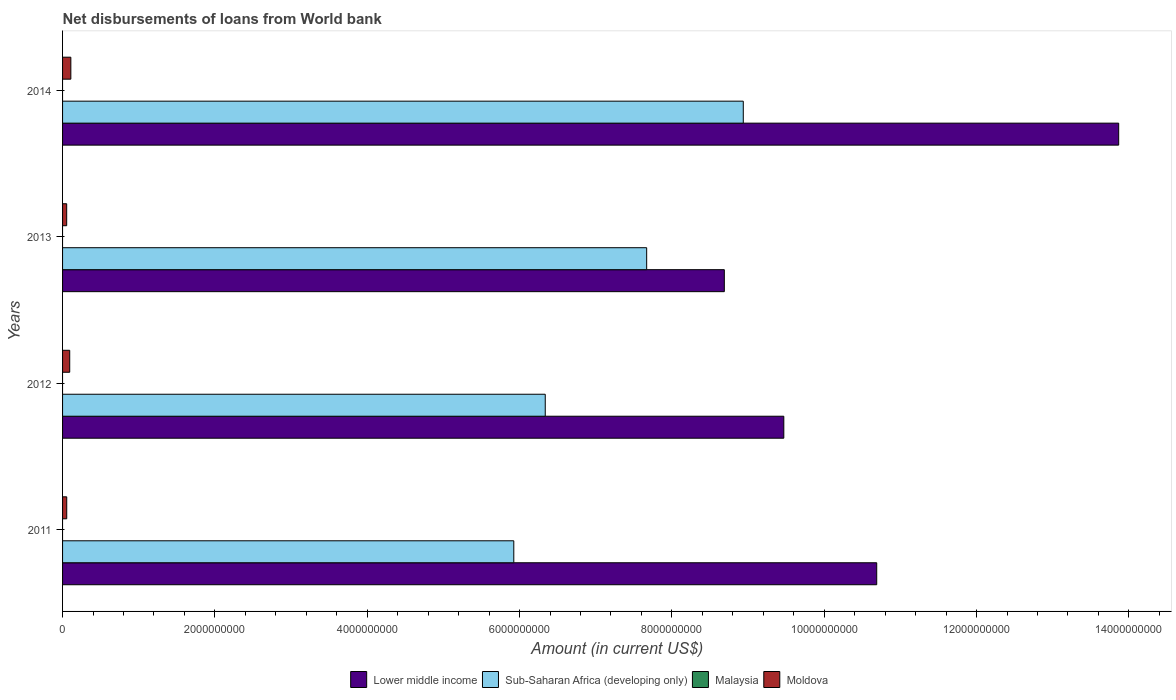What is the label of the 4th group of bars from the top?
Provide a succinct answer. 2011. Across all years, what is the maximum amount of loan disbursed from World Bank in Moldova?
Your response must be concise. 1.09e+08. Across all years, what is the minimum amount of loan disbursed from World Bank in Moldova?
Your response must be concise. 5.40e+07. What is the total amount of loan disbursed from World Bank in Moldova in the graph?
Provide a short and direct response. 3.11e+08. What is the difference between the amount of loan disbursed from World Bank in Moldova in 2011 and that in 2014?
Offer a terse response. -5.39e+07. What is the difference between the amount of loan disbursed from World Bank in Lower middle income in 2013 and the amount of loan disbursed from World Bank in Sub-Saharan Africa (developing only) in 2012?
Make the answer very short. 2.35e+09. What is the average amount of loan disbursed from World Bank in Lower middle income per year?
Ensure brevity in your answer.  1.07e+1. In the year 2012, what is the difference between the amount of loan disbursed from World Bank in Moldova and amount of loan disbursed from World Bank in Sub-Saharan Africa (developing only)?
Provide a short and direct response. -6.24e+09. In how many years, is the amount of loan disbursed from World Bank in Moldova greater than 10800000000 US$?
Keep it short and to the point. 0. What is the ratio of the amount of loan disbursed from World Bank in Sub-Saharan Africa (developing only) in 2013 to that in 2014?
Your answer should be very brief. 0.86. Is the amount of loan disbursed from World Bank in Sub-Saharan Africa (developing only) in 2011 less than that in 2012?
Provide a short and direct response. Yes. Is the difference between the amount of loan disbursed from World Bank in Moldova in 2012 and 2013 greater than the difference between the amount of loan disbursed from World Bank in Sub-Saharan Africa (developing only) in 2012 and 2013?
Give a very brief answer. Yes. What is the difference between the highest and the second highest amount of loan disbursed from World Bank in Moldova?
Keep it short and to the point. 1.47e+07. What is the difference between the highest and the lowest amount of loan disbursed from World Bank in Moldova?
Offer a terse response. 5.46e+07. Is the sum of the amount of loan disbursed from World Bank in Moldova in 2011 and 2012 greater than the maximum amount of loan disbursed from World Bank in Malaysia across all years?
Make the answer very short. Yes. Is it the case that in every year, the sum of the amount of loan disbursed from World Bank in Malaysia and amount of loan disbursed from World Bank in Moldova is greater than the sum of amount of loan disbursed from World Bank in Sub-Saharan Africa (developing only) and amount of loan disbursed from World Bank in Lower middle income?
Offer a very short reply. No. Is it the case that in every year, the sum of the amount of loan disbursed from World Bank in Malaysia and amount of loan disbursed from World Bank in Moldova is greater than the amount of loan disbursed from World Bank in Sub-Saharan Africa (developing only)?
Provide a short and direct response. No. Are the values on the major ticks of X-axis written in scientific E-notation?
Provide a short and direct response. No. Where does the legend appear in the graph?
Your response must be concise. Bottom center. What is the title of the graph?
Make the answer very short. Net disbursements of loans from World bank. What is the Amount (in current US$) in Lower middle income in 2011?
Provide a succinct answer. 1.07e+1. What is the Amount (in current US$) in Sub-Saharan Africa (developing only) in 2011?
Provide a succinct answer. 5.92e+09. What is the Amount (in current US$) in Moldova in 2011?
Your answer should be very brief. 5.47e+07. What is the Amount (in current US$) of Lower middle income in 2012?
Offer a terse response. 9.47e+09. What is the Amount (in current US$) in Sub-Saharan Africa (developing only) in 2012?
Offer a very short reply. 6.34e+09. What is the Amount (in current US$) of Moldova in 2012?
Provide a succinct answer. 9.39e+07. What is the Amount (in current US$) of Lower middle income in 2013?
Your response must be concise. 8.69e+09. What is the Amount (in current US$) of Sub-Saharan Africa (developing only) in 2013?
Your answer should be very brief. 7.67e+09. What is the Amount (in current US$) in Moldova in 2013?
Ensure brevity in your answer.  5.40e+07. What is the Amount (in current US$) in Lower middle income in 2014?
Provide a short and direct response. 1.39e+1. What is the Amount (in current US$) in Sub-Saharan Africa (developing only) in 2014?
Your answer should be very brief. 8.94e+09. What is the Amount (in current US$) in Moldova in 2014?
Ensure brevity in your answer.  1.09e+08. Across all years, what is the maximum Amount (in current US$) of Lower middle income?
Ensure brevity in your answer.  1.39e+1. Across all years, what is the maximum Amount (in current US$) in Sub-Saharan Africa (developing only)?
Provide a short and direct response. 8.94e+09. Across all years, what is the maximum Amount (in current US$) in Moldova?
Make the answer very short. 1.09e+08. Across all years, what is the minimum Amount (in current US$) in Lower middle income?
Make the answer very short. 8.69e+09. Across all years, what is the minimum Amount (in current US$) in Sub-Saharan Africa (developing only)?
Your answer should be very brief. 5.92e+09. Across all years, what is the minimum Amount (in current US$) of Moldova?
Your answer should be very brief. 5.40e+07. What is the total Amount (in current US$) in Lower middle income in the graph?
Your response must be concise. 4.27e+1. What is the total Amount (in current US$) of Sub-Saharan Africa (developing only) in the graph?
Offer a very short reply. 2.89e+1. What is the total Amount (in current US$) in Malaysia in the graph?
Keep it short and to the point. 0. What is the total Amount (in current US$) of Moldova in the graph?
Your answer should be very brief. 3.11e+08. What is the difference between the Amount (in current US$) in Lower middle income in 2011 and that in 2012?
Keep it short and to the point. 1.22e+09. What is the difference between the Amount (in current US$) in Sub-Saharan Africa (developing only) in 2011 and that in 2012?
Offer a very short reply. -4.13e+08. What is the difference between the Amount (in current US$) in Moldova in 2011 and that in 2012?
Your response must be concise. -3.92e+07. What is the difference between the Amount (in current US$) in Lower middle income in 2011 and that in 2013?
Your response must be concise. 2.00e+09. What is the difference between the Amount (in current US$) of Sub-Saharan Africa (developing only) in 2011 and that in 2013?
Offer a very short reply. -1.74e+09. What is the difference between the Amount (in current US$) in Moldova in 2011 and that in 2013?
Your answer should be compact. 7.13e+05. What is the difference between the Amount (in current US$) of Lower middle income in 2011 and that in 2014?
Offer a terse response. -3.18e+09. What is the difference between the Amount (in current US$) in Sub-Saharan Africa (developing only) in 2011 and that in 2014?
Offer a very short reply. -3.01e+09. What is the difference between the Amount (in current US$) of Moldova in 2011 and that in 2014?
Your answer should be very brief. -5.39e+07. What is the difference between the Amount (in current US$) in Lower middle income in 2012 and that in 2013?
Make the answer very short. 7.81e+08. What is the difference between the Amount (in current US$) in Sub-Saharan Africa (developing only) in 2012 and that in 2013?
Ensure brevity in your answer.  -1.33e+09. What is the difference between the Amount (in current US$) of Moldova in 2012 and that in 2013?
Your answer should be very brief. 3.99e+07. What is the difference between the Amount (in current US$) in Lower middle income in 2012 and that in 2014?
Your answer should be very brief. -4.40e+09. What is the difference between the Amount (in current US$) of Sub-Saharan Africa (developing only) in 2012 and that in 2014?
Your response must be concise. -2.60e+09. What is the difference between the Amount (in current US$) of Moldova in 2012 and that in 2014?
Keep it short and to the point. -1.47e+07. What is the difference between the Amount (in current US$) of Lower middle income in 2013 and that in 2014?
Your response must be concise. -5.18e+09. What is the difference between the Amount (in current US$) of Sub-Saharan Africa (developing only) in 2013 and that in 2014?
Offer a very short reply. -1.27e+09. What is the difference between the Amount (in current US$) of Moldova in 2013 and that in 2014?
Keep it short and to the point. -5.46e+07. What is the difference between the Amount (in current US$) in Lower middle income in 2011 and the Amount (in current US$) in Sub-Saharan Africa (developing only) in 2012?
Provide a succinct answer. 4.35e+09. What is the difference between the Amount (in current US$) in Lower middle income in 2011 and the Amount (in current US$) in Moldova in 2012?
Your answer should be very brief. 1.06e+1. What is the difference between the Amount (in current US$) in Sub-Saharan Africa (developing only) in 2011 and the Amount (in current US$) in Moldova in 2012?
Provide a succinct answer. 5.83e+09. What is the difference between the Amount (in current US$) of Lower middle income in 2011 and the Amount (in current US$) of Sub-Saharan Africa (developing only) in 2013?
Offer a very short reply. 3.02e+09. What is the difference between the Amount (in current US$) of Lower middle income in 2011 and the Amount (in current US$) of Moldova in 2013?
Your response must be concise. 1.06e+1. What is the difference between the Amount (in current US$) in Sub-Saharan Africa (developing only) in 2011 and the Amount (in current US$) in Moldova in 2013?
Provide a succinct answer. 5.87e+09. What is the difference between the Amount (in current US$) in Lower middle income in 2011 and the Amount (in current US$) in Sub-Saharan Africa (developing only) in 2014?
Give a very brief answer. 1.75e+09. What is the difference between the Amount (in current US$) in Lower middle income in 2011 and the Amount (in current US$) in Moldova in 2014?
Offer a terse response. 1.06e+1. What is the difference between the Amount (in current US$) of Sub-Saharan Africa (developing only) in 2011 and the Amount (in current US$) of Moldova in 2014?
Keep it short and to the point. 5.82e+09. What is the difference between the Amount (in current US$) in Lower middle income in 2012 and the Amount (in current US$) in Sub-Saharan Africa (developing only) in 2013?
Give a very brief answer. 1.80e+09. What is the difference between the Amount (in current US$) in Lower middle income in 2012 and the Amount (in current US$) in Moldova in 2013?
Offer a very short reply. 9.42e+09. What is the difference between the Amount (in current US$) in Sub-Saharan Africa (developing only) in 2012 and the Amount (in current US$) in Moldova in 2013?
Ensure brevity in your answer.  6.28e+09. What is the difference between the Amount (in current US$) of Lower middle income in 2012 and the Amount (in current US$) of Sub-Saharan Africa (developing only) in 2014?
Your response must be concise. 5.32e+08. What is the difference between the Amount (in current US$) of Lower middle income in 2012 and the Amount (in current US$) of Moldova in 2014?
Provide a short and direct response. 9.36e+09. What is the difference between the Amount (in current US$) in Sub-Saharan Africa (developing only) in 2012 and the Amount (in current US$) in Moldova in 2014?
Ensure brevity in your answer.  6.23e+09. What is the difference between the Amount (in current US$) of Lower middle income in 2013 and the Amount (in current US$) of Sub-Saharan Africa (developing only) in 2014?
Offer a terse response. -2.49e+08. What is the difference between the Amount (in current US$) in Lower middle income in 2013 and the Amount (in current US$) in Moldova in 2014?
Provide a succinct answer. 8.58e+09. What is the difference between the Amount (in current US$) in Sub-Saharan Africa (developing only) in 2013 and the Amount (in current US$) in Moldova in 2014?
Your response must be concise. 7.56e+09. What is the average Amount (in current US$) of Lower middle income per year?
Provide a succinct answer. 1.07e+1. What is the average Amount (in current US$) of Sub-Saharan Africa (developing only) per year?
Provide a succinct answer. 7.22e+09. What is the average Amount (in current US$) of Moldova per year?
Keep it short and to the point. 7.78e+07. In the year 2011, what is the difference between the Amount (in current US$) of Lower middle income and Amount (in current US$) of Sub-Saharan Africa (developing only)?
Your answer should be compact. 4.76e+09. In the year 2011, what is the difference between the Amount (in current US$) of Lower middle income and Amount (in current US$) of Moldova?
Make the answer very short. 1.06e+1. In the year 2011, what is the difference between the Amount (in current US$) of Sub-Saharan Africa (developing only) and Amount (in current US$) of Moldova?
Give a very brief answer. 5.87e+09. In the year 2012, what is the difference between the Amount (in current US$) of Lower middle income and Amount (in current US$) of Sub-Saharan Africa (developing only)?
Your answer should be compact. 3.13e+09. In the year 2012, what is the difference between the Amount (in current US$) in Lower middle income and Amount (in current US$) in Moldova?
Keep it short and to the point. 9.38e+09. In the year 2012, what is the difference between the Amount (in current US$) in Sub-Saharan Africa (developing only) and Amount (in current US$) in Moldova?
Provide a succinct answer. 6.24e+09. In the year 2013, what is the difference between the Amount (in current US$) of Lower middle income and Amount (in current US$) of Sub-Saharan Africa (developing only)?
Give a very brief answer. 1.02e+09. In the year 2013, what is the difference between the Amount (in current US$) in Lower middle income and Amount (in current US$) in Moldova?
Your answer should be very brief. 8.63e+09. In the year 2013, what is the difference between the Amount (in current US$) of Sub-Saharan Africa (developing only) and Amount (in current US$) of Moldova?
Offer a very short reply. 7.61e+09. In the year 2014, what is the difference between the Amount (in current US$) in Lower middle income and Amount (in current US$) in Sub-Saharan Africa (developing only)?
Provide a succinct answer. 4.93e+09. In the year 2014, what is the difference between the Amount (in current US$) in Lower middle income and Amount (in current US$) in Moldova?
Provide a succinct answer. 1.38e+1. In the year 2014, what is the difference between the Amount (in current US$) of Sub-Saharan Africa (developing only) and Amount (in current US$) of Moldova?
Keep it short and to the point. 8.83e+09. What is the ratio of the Amount (in current US$) of Lower middle income in 2011 to that in 2012?
Keep it short and to the point. 1.13. What is the ratio of the Amount (in current US$) in Sub-Saharan Africa (developing only) in 2011 to that in 2012?
Ensure brevity in your answer.  0.93. What is the ratio of the Amount (in current US$) of Moldova in 2011 to that in 2012?
Provide a short and direct response. 0.58. What is the ratio of the Amount (in current US$) of Lower middle income in 2011 to that in 2013?
Provide a succinct answer. 1.23. What is the ratio of the Amount (in current US$) in Sub-Saharan Africa (developing only) in 2011 to that in 2013?
Your response must be concise. 0.77. What is the ratio of the Amount (in current US$) in Moldova in 2011 to that in 2013?
Ensure brevity in your answer.  1.01. What is the ratio of the Amount (in current US$) in Lower middle income in 2011 to that in 2014?
Provide a short and direct response. 0.77. What is the ratio of the Amount (in current US$) of Sub-Saharan Africa (developing only) in 2011 to that in 2014?
Make the answer very short. 0.66. What is the ratio of the Amount (in current US$) of Moldova in 2011 to that in 2014?
Give a very brief answer. 0.5. What is the ratio of the Amount (in current US$) in Lower middle income in 2012 to that in 2013?
Offer a very short reply. 1.09. What is the ratio of the Amount (in current US$) in Sub-Saharan Africa (developing only) in 2012 to that in 2013?
Your answer should be compact. 0.83. What is the ratio of the Amount (in current US$) in Moldova in 2012 to that in 2013?
Give a very brief answer. 1.74. What is the ratio of the Amount (in current US$) in Lower middle income in 2012 to that in 2014?
Provide a succinct answer. 0.68. What is the ratio of the Amount (in current US$) of Sub-Saharan Africa (developing only) in 2012 to that in 2014?
Make the answer very short. 0.71. What is the ratio of the Amount (in current US$) in Moldova in 2012 to that in 2014?
Your answer should be compact. 0.86. What is the ratio of the Amount (in current US$) in Lower middle income in 2013 to that in 2014?
Offer a terse response. 0.63. What is the ratio of the Amount (in current US$) in Sub-Saharan Africa (developing only) in 2013 to that in 2014?
Give a very brief answer. 0.86. What is the ratio of the Amount (in current US$) of Moldova in 2013 to that in 2014?
Provide a short and direct response. 0.5. What is the difference between the highest and the second highest Amount (in current US$) in Lower middle income?
Keep it short and to the point. 3.18e+09. What is the difference between the highest and the second highest Amount (in current US$) in Sub-Saharan Africa (developing only)?
Keep it short and to the point. 1.27e+09. What is the difference between the highest and the second highest Amount (in current US$) of Moldova?
Keep it short and to the point. 1.47e+07. What is the difference between the highest and the lowest Amount (in current US$) of Lower middle income?
Your response must be concise. 5.18e+09. What is the difference between the highest and the lowest Amount (in current US$) in Sub-Saharan Africa (developing only)?
Ensure brevity in your answer.  3.01e+09. What is the difference between the highest and the lowest Amount (in current US$) in Moldova?
Make the answer very short. 5.46e+07. 